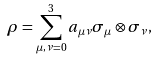Convert formula to latex. <formula><loc_0><loc_0><loc_500><loc_500>\rho = \sum _ { \mu , \nu = 0 } ^ { 3 } a _ { \mu \nu } \sigma _ { \mu } \otimes \sigma _ { \nu } ,</formula> 